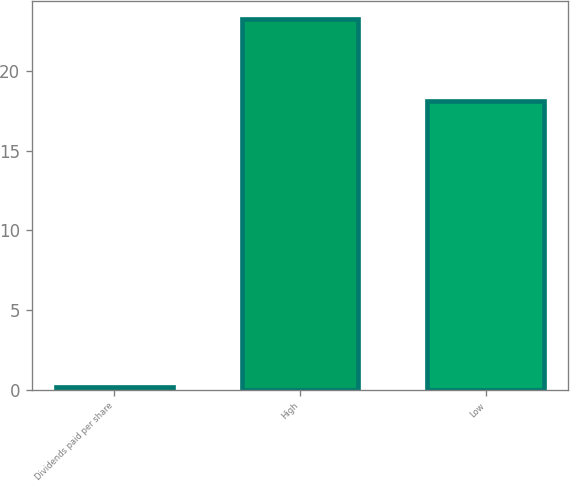<chart> <loc_0><loc_0><loc_500><loc_500><bar_chart><fcel>Dividends paid per share<fcel>High<fcel>Low<nl><fcel>0.15<fcel>23.23<fcel>18.1<nl></chart> 